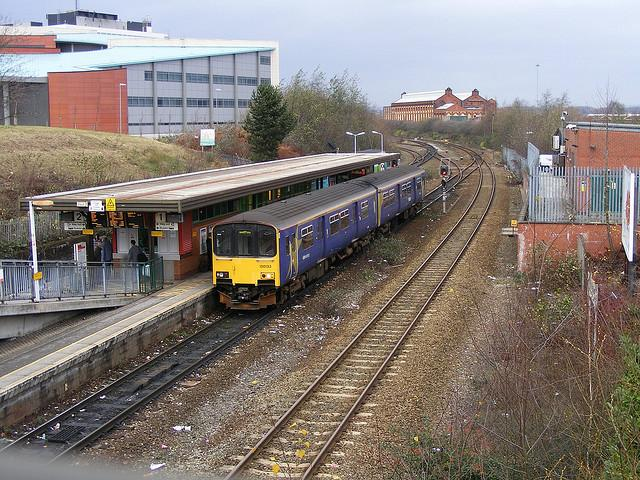At which building does the purple train stop? train station 